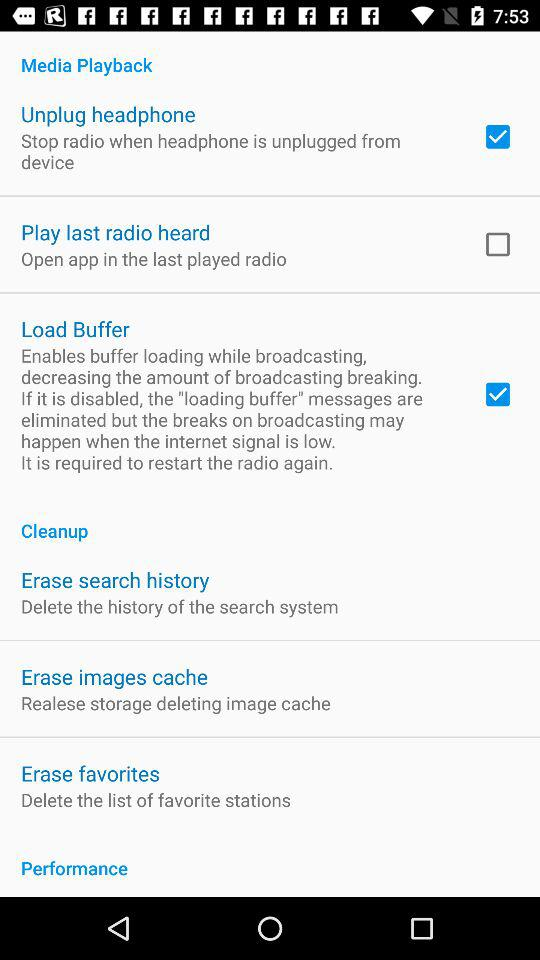What are the options available in "Media Playback"? The available options are "Unplug headphone", "Play last radio heard" and "Load Buffer". 